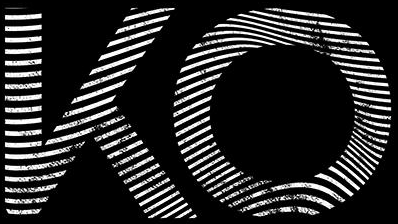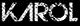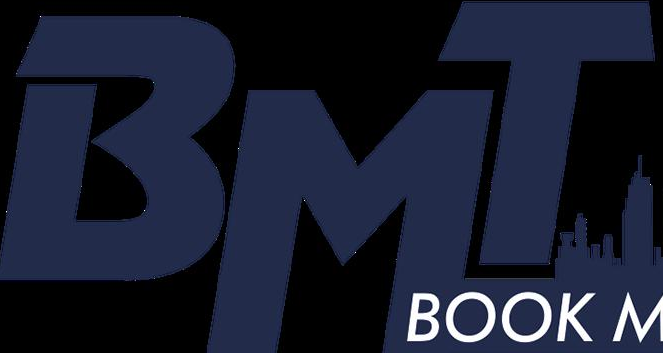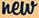Read the text content from these images in order, separated by a semicolon. KO; KΛROL; BMT; new 